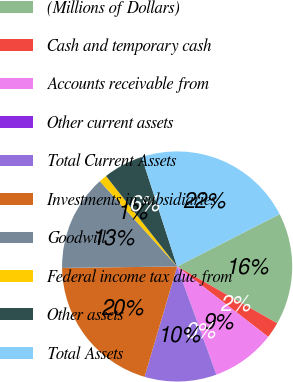Convert chart to OTSL. <chart><loc_0><loc_0><loc_500><loc_500><pie_chart><fcel>(Millions of Dollars)<fcel>Cash and temporary cash<fcel>Accounts receivable from<fcel>Other current assets<fcel>Total Current Assets<fcel>Investments in subsidiaries<fcel>Goodwill<fcel>Federal income tax due from<fcel>Other assets<fcel>Total Assets<nl><fcel>15.73%<fcel>2.25%<fcel>8.99%<fcel>0.0%<fcel>10.11%<fcel>20.22%<fcel>13.48%<fcel>1.12%<fcel>5.62%<fcel>22.47%<nl></chart> 